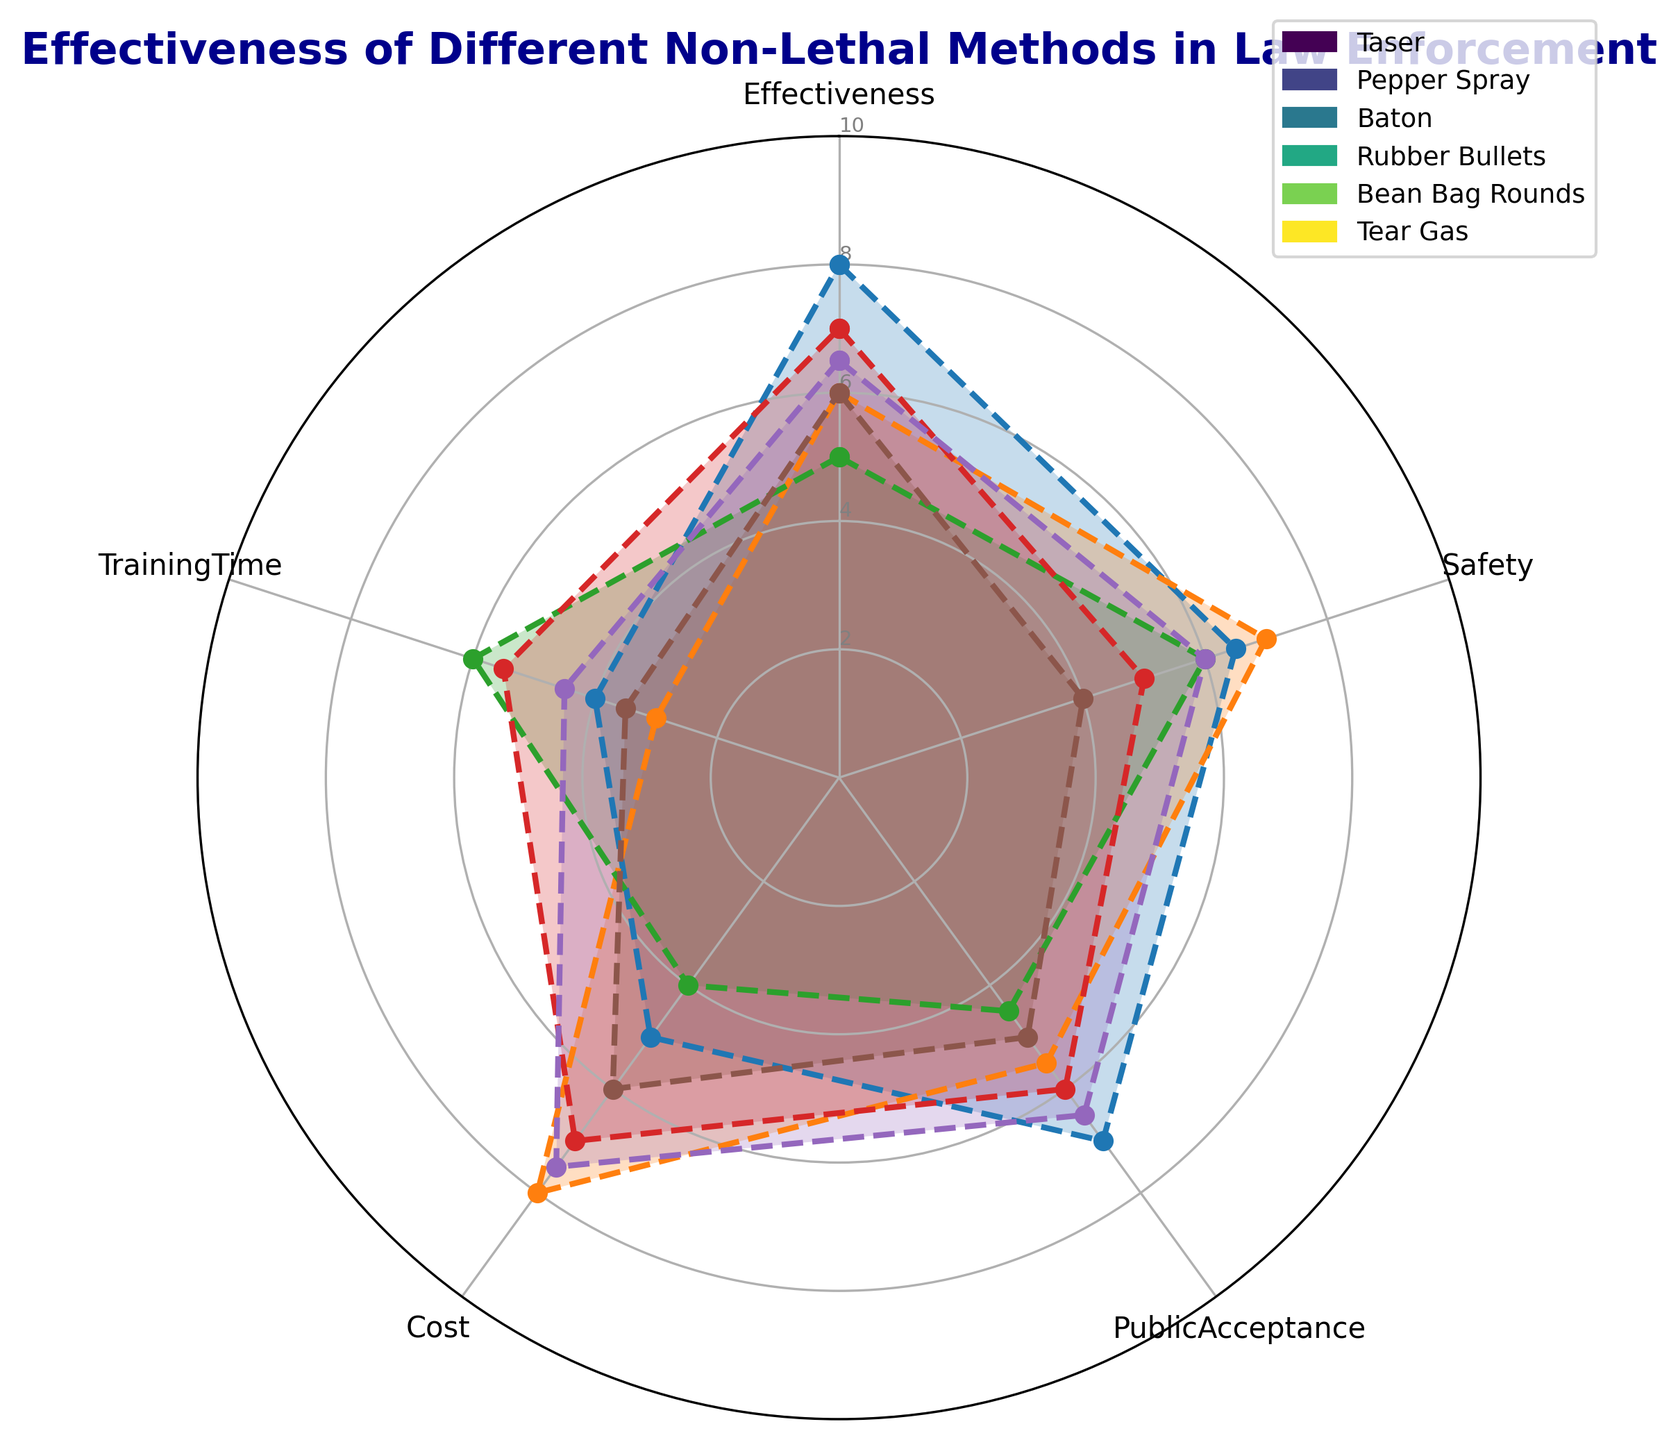Which non-lethal method has the highest effectiveness score? Compare the effectiveness scores of all methods. The Taser has the highest score with 8.
Answer: Taser Which non-lethal method requires the longest training time? Compare the training times for each method. The Baton requires the longest training time with a score of 6.
Answer: Baton What's the average public acceptance score for Taser and Pepper Spray? Add the public acceptance scores for Taser (7) and Pepper Spray (5.5), then divide by 2. The average is (7 + 5.5)/2 = 6.25.
Answer: 6.25 Which method is considered safer: Pepper Spray or Tear Gas? Compare the safety scores of Pepper Spray (7) and Tear Gas (4). Pepper Spray has a higher safety score.
Answer: Pepper Spray Among Taser, Rubber Bullets, and Bean Bag Rounds, which method has the lowest cost? Compare the cost scores of Taser (5), Rubber Bullets (7), and Bean Bag Rounds (7.5). Taser has the lowest cost.
Answer: Taser What is the total score (sum of all metrics) for Bean Bag Rounds? Add the scores for effectiveness (6.5), safety (6), public acceptance (6.5), cost (7.5), and training time (4.5). The total score is 6.5 + 6 + 6.5 + 7.5 + 4.5 = 31.
Answer: 31 Which method scores highest on effectiveness but lowest on safety? The Taser scores highest on effectiveness with 8, but its safety score is 6.5, which is not the lowest. Tear Gas has the lowest safety score of 4.
Answer: None Which two methods are closest in terms of overall balance across all metrics? Compare the radar plots visually. Pepper Spray and Bean Bag Rounds show similar profiles across all metrics.
Answer: Pepper Spray and Bean Bag Rounds Between Pepper Spray and Baton, which one has a higher total score (sum of all metrics)? Sum the scores for Pepper Spray (effectiveness 6, safety 7, public acceptance 5.5, cost 8, training time 3) and Baton (effectiveness 5, safety 6, public acceptance 4.5, cost 4, training time 6). Total for Pepper Spray = 6 + 7 + 5.5 + 8 + 3 = 29.5, and for Baton = 5 + 6 + 4.5 + 4 + 6 = 25.5.
Answer: Pepper Spray Which method has the most evenly balanced profile across all metrics? Visually assess the radar chart for the method whose metrics are closest to each other. Bean Bag Rounds have relatively balanced scores across all metrics.
Answer: Bean Bag Rounds 